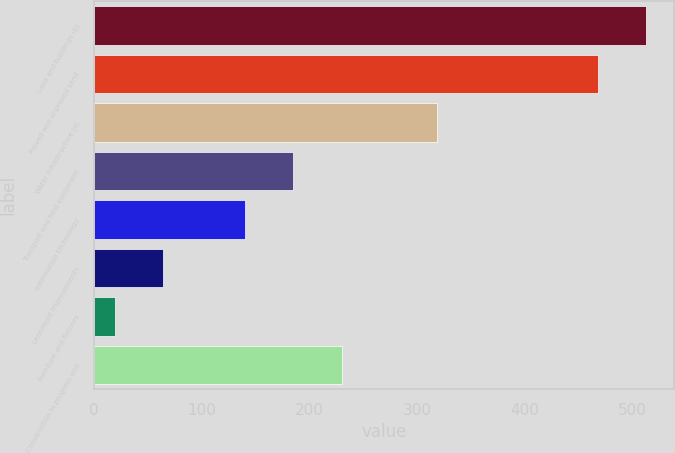<chart> <loc_0><loc_0><loc_500><loc_500><bar_chart><fcel>Land and buildings (b)<fcel>Proved and unproved sand<fcel>Water infrastructure (d)<fcel>Transport and field equipment<fcel>Information technology<fcel>Leasehold improvements<fcel>Furniture and fixtures<fcel>Construction in progress and<nl><fcel>513<fcel>468<fcel>319<fcel>185<fcel>140<fcel>64<fcel>19<fcel>230<nl></chart> 